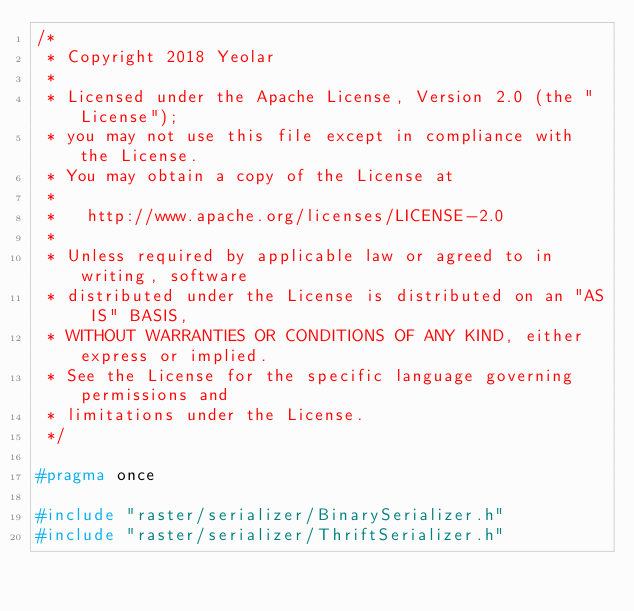<code> <loc_0><loc_0><loc_500><loc_500><_C_>/*
 * Copyright 2018 Yeolar
 *
 * Licensed under the Apache License, Version 2.0 (the "License");
 * you may not use this file except in compliance with the License.
 * You may obtain a copy of the License at
 *
 *   http://www.apache.org/licenses/LICENSE-2.0
 *
 * Unless required by applicable law or agreed to in writing, software
 * distributed under the License is distributed on an "AS IS" BASIS,
 * WITHOUT WARRANTIES OR CONDITIONS OF ANY KIND, either express or implied.
 * See the License for the specific language governing permissions and
 * limitations under the License.
 */

#pragma once

#include "raster/serializer/BinarySerializer.h"
#include "raster/serializer/ThriftSerializer.h"
</code> 